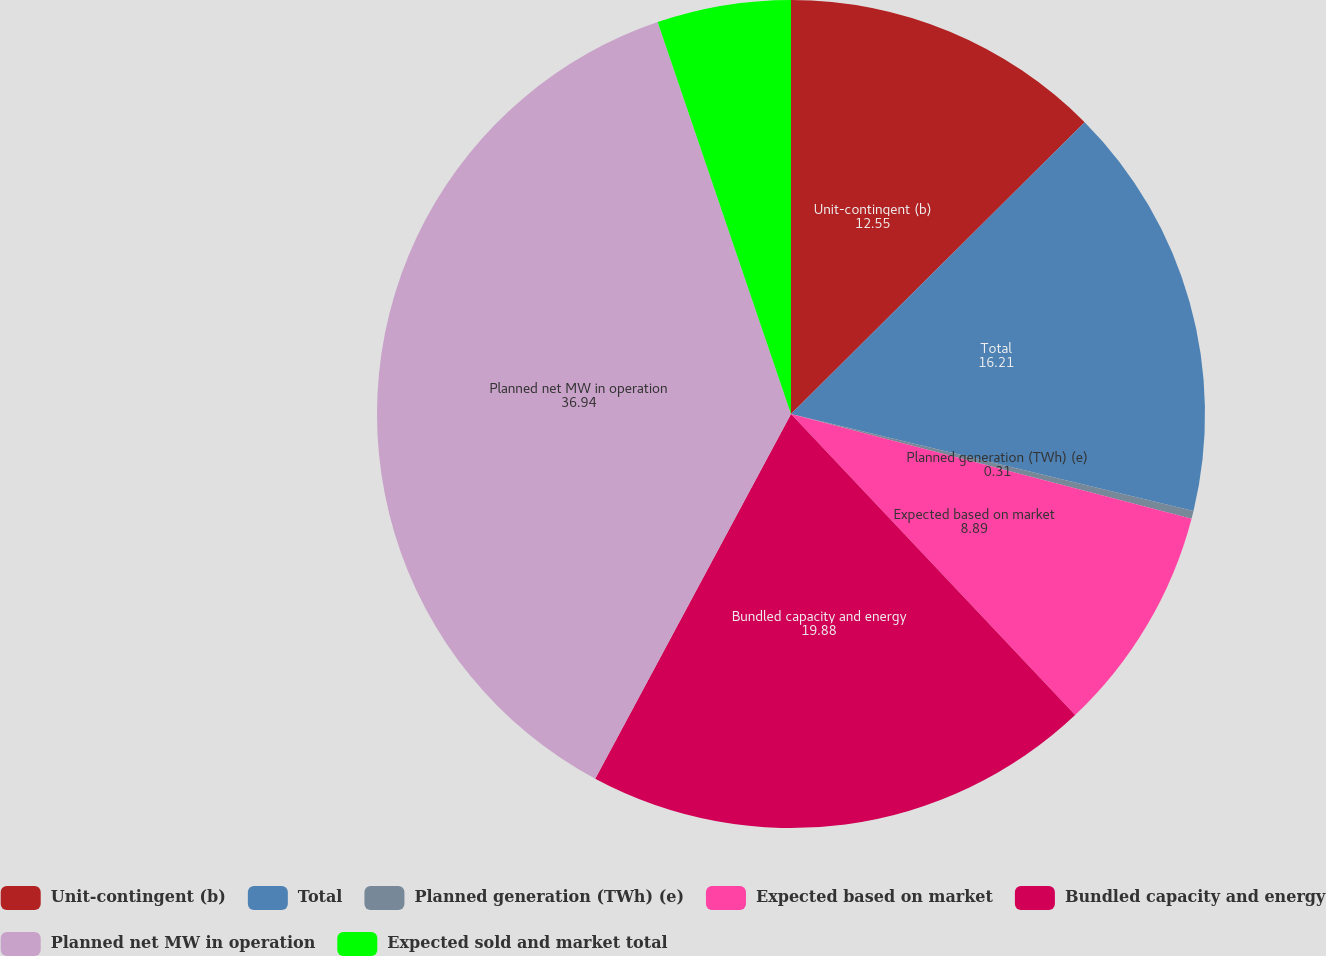Convert chart to OTSL. <chart><loc_0><loc_0><loc_500><loc_500><pie_chart><fcel>Unit-contingent (b)<fcel>Total<fcel>Planned generation (TWh) (e)<fcel>Expected based on market<fcel>Bundled capacity and energy<fcel>Planned net MW in operation<fcel>Expected sold and market total<nl><fcel>12.55%<fcel>16.21%<fcel>0.31%<fcel>8.89%<fcel>19.88%<fcel>36.94%<fcel>5.22%<nl></chart> 